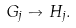Convert formula to latex. <formula><loc_0><loc_0><loc_500><loc_500>G _ { j } \to H _ { j } .</formula> 